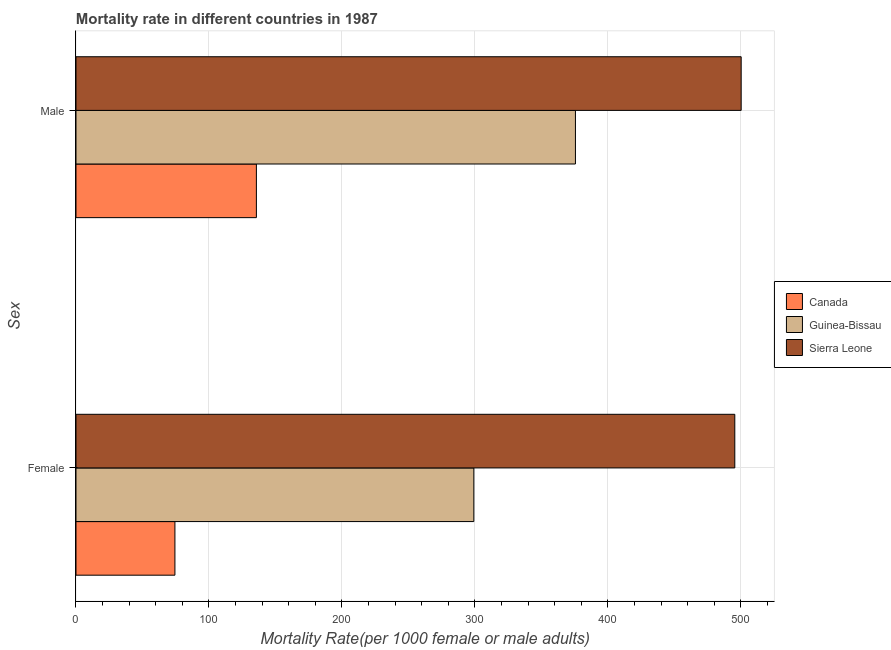How many groups of bars are there?
Ensure brevity in your answer.  2. Are the number of bars per tick equal to the number of legend labels?
Ensure brevity in your answer.  Yes. Are the number of bars on each tick of the Y-axis equal?
Make the answer very short. Yes. How many bars are there on the 2nd tick from the top?
Keep it short and to the point. 3. What is the label of the 1st group of bars from the top?
Make the answer very short. Male. What is the male mortality rate in Canada?
Provide a succinct answer. 135.68. Across all countries, what is the maximum male mortality rate?
Give a very brief answer. 500.28. Across all countries, what is the minimum male mortality rate?
Provide a succinct answer. 135.68. In which country was the female mortality rate maximum?
Offer a very short reply. Sierra Leone. What is the total male mortality rate in the graph?
Provide a succinct answer. 1011.6. What is the difference between the male mortality rate in Guinea-Bissau and that in Canada?
Your response must be concise. 239.95. What is the difference between the male mortality rate in Sierra Leone and the female mortality rate in Guinea-Bissau?
Your answer should be compact. 201.07. What is the average female mortality rate per country?
Provide a short and direct response. 289.7. What is the difference between the male mortality rate and female mortality rate in Sierra Leone?
Ensure brevity in your answer.  4.79. What is the ratio of the male mortality rate in Sierra Leone to that in Canada?
Provide a succinct answer. 3.69. Is the female mortality rate in Guinea-Bissau less than that in Sierra Leone?
Make the answer very short. Yes. In how many countries, is the male mortality rate greater than the average male mortality rate taken over all countries?
Your answer should be very brief. 2. How many bars are there?
Your response must be concise. 6. What is the difference between two consecutive major ticks on the X-axis?
Offer a very short reply. 100. Does the graph contain any zero values?
Make the answer very short. No. Where does the legend appear in the graph?
Keep it short and to the point. Center right. How are the legend labels stacked?
Make the answer very short. Vertical. What is the title of the graph?
Provide a short and direct response. Mortality rate in different countries in 1987. Does "Isle of Man" appear as one of the legend labels in the graph?
Offer a terse response. No. What is the label or title of the X-axis?
Your response must be concise. Mortality Rate(per 1000 female or male adults). What is the label or title of the Y-axis?
Keep it short and to the point. Sex. What is the Mortality Rate(per 1000 female or male adults) in Canada in Female?
Keep it short and to the point. 74.4. What is the Mortality Rate(per 1000 female or male adults) in Guinea-Bissau in Female?
Your answer should be compact. 299.21. What is the Mortality Rate(per 1000 female or male adults) in Sierra Leone in Female?
Ensure brevity in your answer.  495.49. What is the Mortality Rate(per 1000 female or male adults) of Canada in Male?
Keep it short and to the point. 135.68. What is the Mortality Rate(per 1000 female or male adults) of Guinea-Bissau in Male?
Make the answer very short. 375.64. What is the Mortality Rate(per 1000 female or male adults) of Sierra Leone in Male?
Offer a terse response. 500.28. Across all Sex, what is the maximum Mortality Rate(per 1000 female or male adults) in Canada?
Offer a terse response. 135.68. Across all Sex, what is the maximum Mortality Rate(per 1000 female or male adults) in Guinea-Bissau?
Offer a terse response. 375.64. Across all Sex, what is the maximum Mortality Rate(per 1000 female or male adults) in Sierra Leone?
Offer a terse response. 500.28. Across all Sex, what is the minimum Mortality Rate(per 1000 female or male adults) in Canada?
Your answer should be very brief. 74.4. Across all Sex, what is the minimum Mortality Rate(per 1000 female or male adults) of Guinea-Bissau?
Provide a short and direct response. 299.21. Across all Sex, what is the minimum Mortality Rate(per 1000 female or male adults) in Sierra Leone?
Provide a succinct answer. 495.49. What is the total Mortality Rate(per 1000 female or male adults) of Canada in the graph?
Offer a terse response. 210.09. What is the total Mortality Rate(per 1000 female or male adults) of Guinea-Bissau in the graph?
Your answer should be very brief. 674.85. What is the total Mortality Rate(per 1000 female or male adults) of Sierra Leone in the graph?
Ensure brevity in your answer.  995.76. What is the difference between the Mortality Rate(per 1000 female or male adults) in Canada in Female and that in Male?
Ensure brevity in your answer.  -61.28. What is the difference between the Mortality Rate(per 1000 female or male adults) of Guinea-Bissau in Female and that in Male?
Offer a terse response. -76.43. What is the difference between the Mortality Rate(per 1000 female or male adults) of Sierra Leone in Female and that in Male?
Offer a terse response. -4.79. What is the difference between the Mortality Rate(per 1000 female or male adults) in Canada in Female and the Mortality Rate(per 1000 female or male adults) in Guinea-Bissau in Male?
Offer a terse response. -301.24. What is the difference between the Mortality Rate(per 1000 female or male adults) of Canada in Female and the Mortality Rate(per 1000 female or male adults) of Sierra Leone in Male?
Your response must be concise. -425.88. What is the difference between the Mortality Rate(per 1000 female or male adults) of Guinea-Bissau in Female and the Mortality Rate(per 1000 female or male adults) of Sierra Leone in Male?
Make the answer very short. -201.07. What is the average Mortality Rate(per 1000 female or male adults) of Canada per Sex?
Your answer should be very brief. 105.04. What is the average Mortality Rate(per 1000 female or male adults) in Guinea-Bissau per Sex?
Provide a succinct answer. 337.42. What is the average Mortality Rate(per 1000 female or male adults) in Sierra Leone per Sex?
Offer a very short reply. 497.88. What is the difference between the Mortality Rate(per 1000 female or male adults) of Canada and Mortality Rate(per 1000 female or male adults) of Guinea-Bissau in Female?
Provide a succinct answer. -224.81. What is the difference between the Mortality Rate(per 1000 female or male adults) of Canada and Mortality Rate(per 1000 female or male adults) of Sierra Leone in Female?
Give a very brief answer. -421.08. What is the difference between the Mortality Rate(per 1000 female or male adults) in Guinea-Bissau and Mortality Rate(per 1000 female or male adults) in Sierra Leone in Female?
Your answer should be very brief. -196.28. What is the difference between the Mortality Rate(per 1000 female or male adults) of Canada and Mortality Rate(per 1000 female or male adults) of Guinea-Bissau in Male?
Your answer should be compact. -239.95. What is the difference between the Mortality Rate(per 1000 female or male adults) of Canada and Mortality Rate(per 1000 female or male adults) of Sierra Leone in Male?
Offer a very short reply. -364.6. What is the difference between the Mortality Rate(per 1000 female or male adults) of Guinea-Bissau and Mortality Rate(per 1000 female or male adults) of Sierra Leone in Male?
Your response must be concise. -124.64. What is the ratio of the Mortality Rate(per 1000 female or male adults) of Canada in Female to that in Male?
Provide a short and direct response. 0.55. What is the ratio of the Mortality Rate(per 1000 female or male adults) of Guinea-Bissau in Female to that in Male?
Make the answer very short. 0.8. What is the ratio of the Mortality Rate(per 1000 female or male adults) in Sierra Leone in Female to that in Male?
Your answer should be compact. 0.99. What is the difference between the highest and the second highest Mortality Rate(per 1000 female or male adults) of Canada?
Provide a succinct answer. 61.28. What is the difference between the highest and the second highest Mortality Rate(per 1000 female or male adults) of Guinea-Bissau?
Provide a succinct answer. 76.43. What is the difference between the highest and the second highest Mortality Rate(per 1000 female or male adults) of Sierra Leone?
Give a very brief answer. 4.79. What is the difference between the highest and the lowest Mortality Rate(per 1000 female or male adults) of Canada?
Give a very brief answer. 61.28. What is the difference between the highest and the lowest Mortality Rate(per 1000 female or male adults) in Guinea-Bissau?
Provide a short and direct response. 76.43. What is the difference between the highest and the lowest Mortality Rate(per 1000 female or male adults) in Sierra Leone?
Your answer should be very brief. 4.79. 